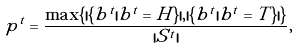<formula> <loc_0><loc_0><loc_500><loc_500>p ^ { t } = \frac { \max \{ | \{ b ^ { t } | b ^ { t } = H \} | , | \{ b ^ { t } | b ^ { t } = T \} | \} } { | S ^ { t } | } ,</formula> 